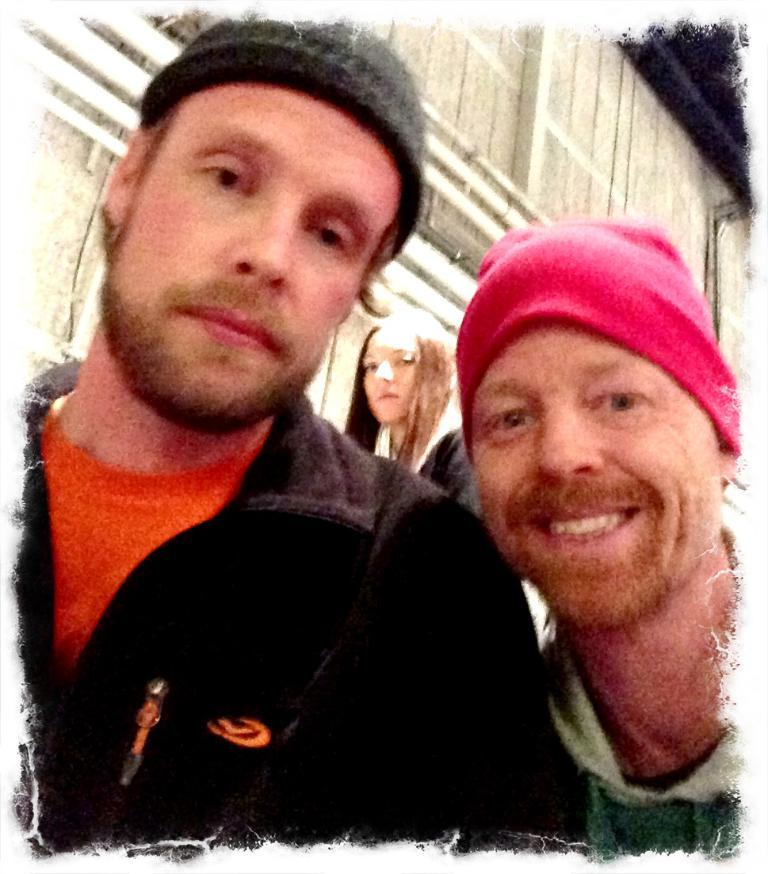How many people are in the image? There is a group of people in the image. What are some of the people in the group wearing? Some people in the group are wearing caps. What can be seen in the background of the image? There is a building in the background of the image. What statement is being made by the smoke in the image? There is no smoke present in the image, so it is not possible to answer that question. 